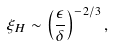<formula> <loc_0><loc_0><loc_500><loc_500>\xi _ { H } \sim \left ( \frac { \epsilon } { \delta } \right ) ^ { - 2 / 3 } ,</formula> 